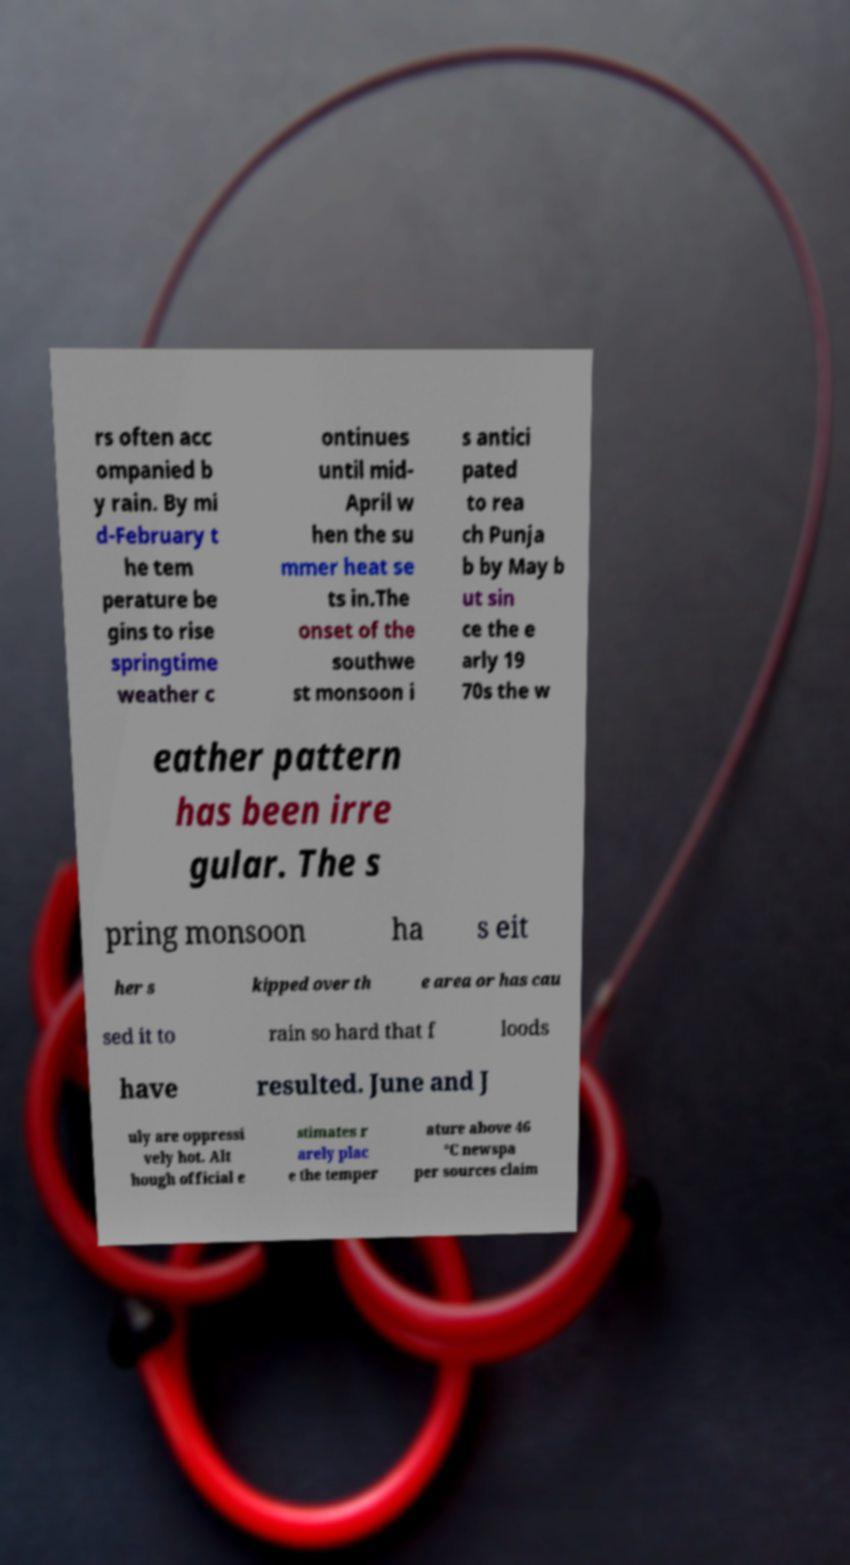I need the written content from this picture converted into text. Can you do that? rs often acc ompanied b y rain. By mi d-February t he tem perature be gins to rise springtime weather c ontinues until mid- April w hen the su mmer heat se ts in.The onset of the southwe st monsoon i s antici pated to rea ch Punja b by May b ut sin ce the e arly 19 70s the w eather pattern has been irre gular. The s pring monsoon ha s eit her s kipped over th e area or has cau sed it to rain so hard that f loods have resulted. June and J uly are oppressi vely hot. Alt hough official e stimates r arely plac e the temper ature above 46 °C newspa per sources claim 